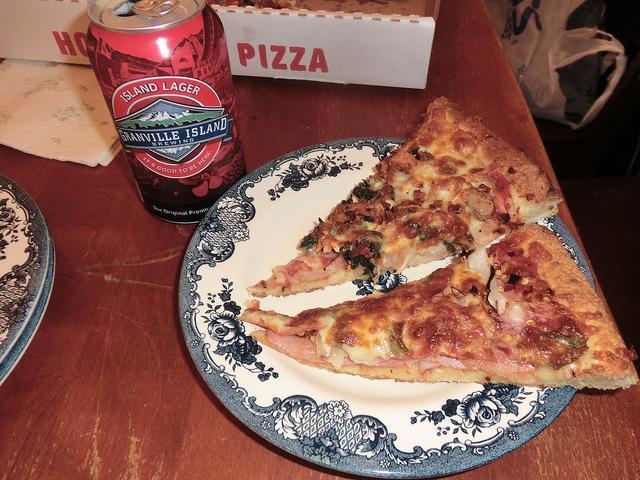How many slices on the plate?
Give a very brief answer. 2. How many pizzas are in the photo?
Give a very brief answer. 2. 